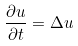<formula> <loc_0><loc_0><loc_500><loc_500>\frac { \partial u } { \partial t } = \Delta u</formula> 